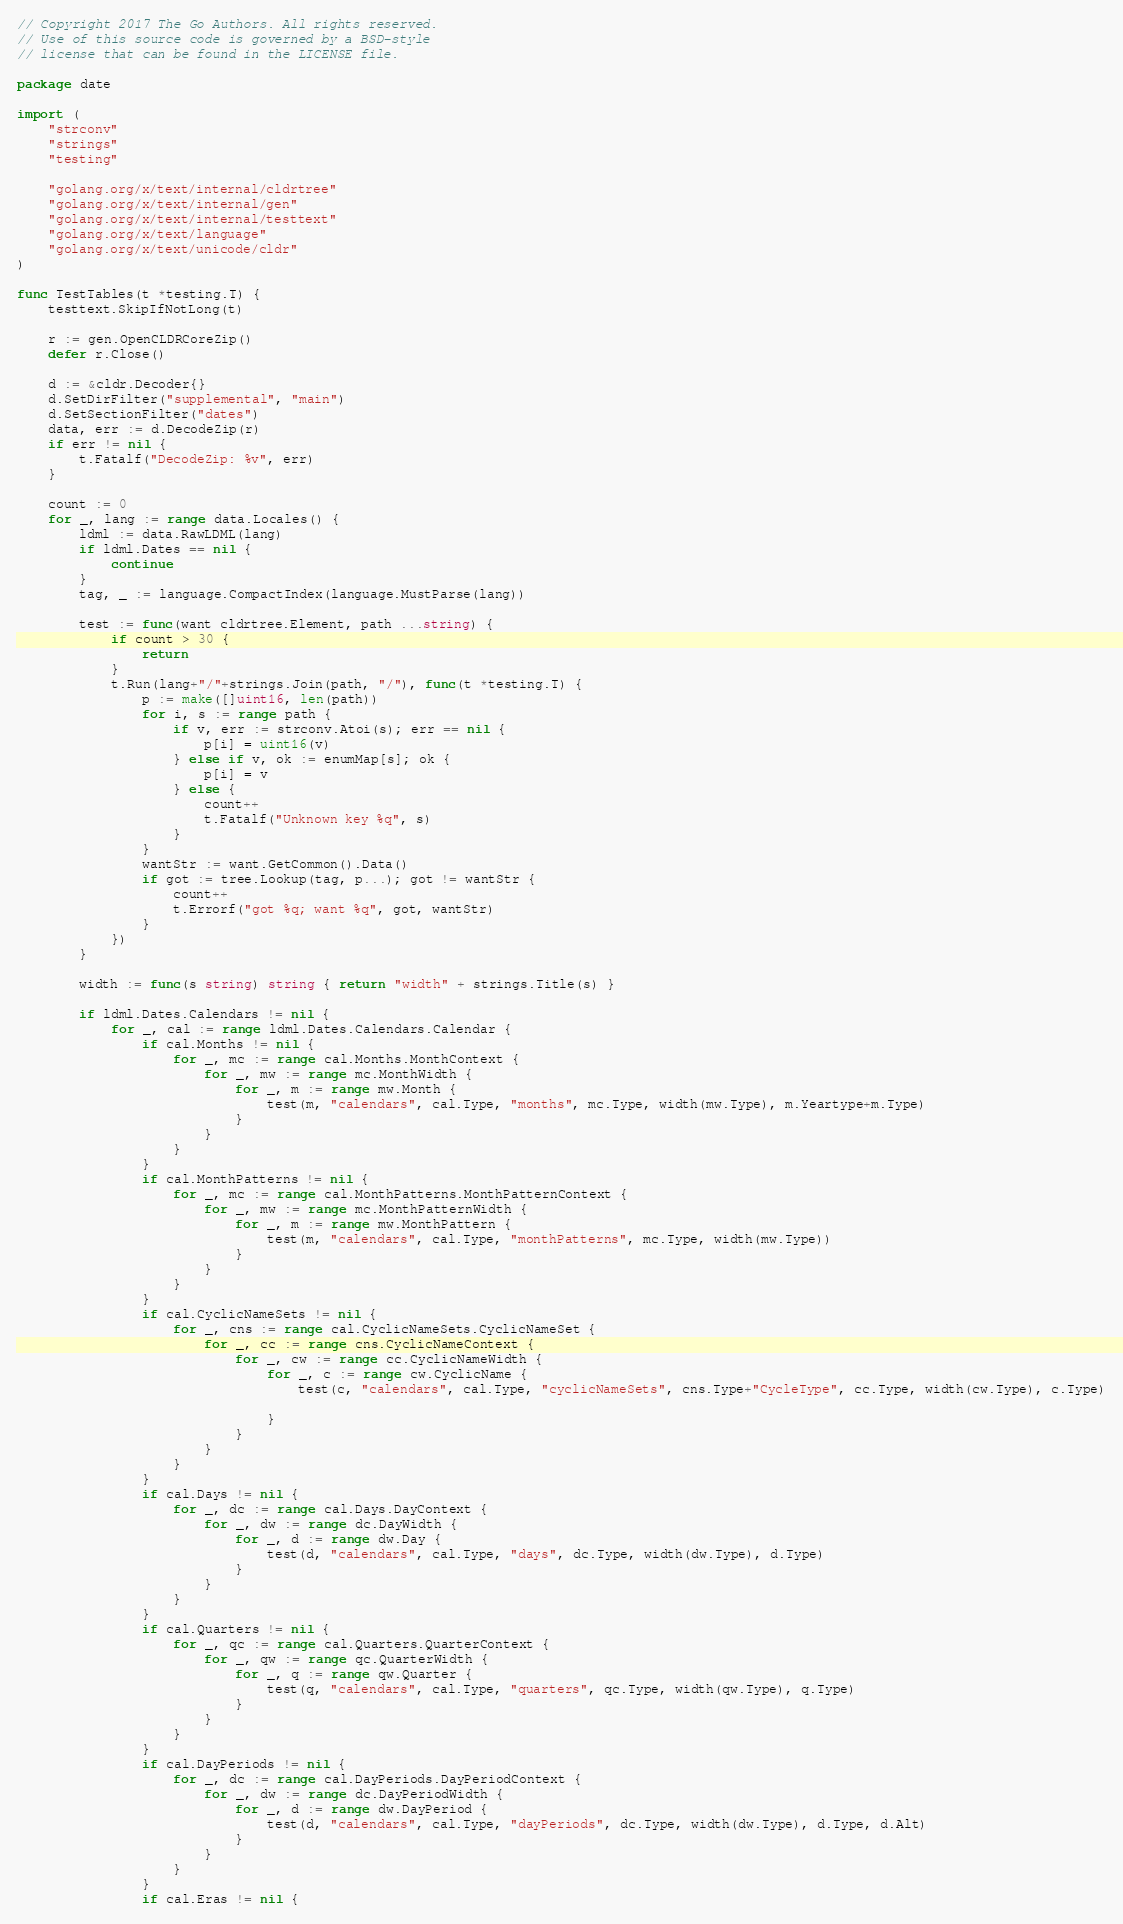Convert code to text. <code><loc_0><loc_0><loc_500><loc_500><_Go_>// Copyright 2017 The Go Authors. All rights reserved.
// Use of this source code is governed by a BSD-style
// license that can be found in the LICENSE file.

package date

import (
	"strconv"
	"strings"
	"testing"

	"golang.org/x/text/internal/cldrtree"
	"golang.org/x/text/internal/gen"
	"golang.org/x/text/internal/testtext"
	"golang.org/x/text/language"
	"golang.org/x/text/unicode/cldr"
)

func TestTables(t *testing.T) {
	testtext.SkipIfNotLong(t)

	r := gen.OpenCLDRCoreZip()
	defer r.Close()

	d := &cldr.Decoder{}
	d.SetDirFilter("supplemental", "main")
	d.SetSectionFilter("dates")
	data, err := d.DecodeZip(r)
	if err != nil {
		t.Fatalf("DecodeZip: %v", err)
	}

	count := 0
	for _, lang := range data.Locales() {
		ldml := data.RawLDML(lang)
		if ldml.Dates == nil {
			continue
		}
		tag, _ := language.CompactIndex(language.MustParse(lang))

		test := func(want cldrtree.Element, path ...string) {
			if count > 30 {
				return
			}
			t.Run(lang+"/"+strings.Join(path, "/"), func(t *testing.T) {
				p := make([]uint16, len(path))
				for i, s := range path {
					if v, err := strconv.Atoi(s); err == nil {
						p[i] = uint16(v)
					} else if v, ok := enumMap[s]; ok {
						p[i] = v
					} else {
						count++
						t.Fatalf("Unknown key %q", s)
					}
				}
				wantStr := want.GetCommon().Data()
				if got := tree.Lookup(tag, p...); got != wantStr {
					count++
					t.Errorf("got %q; want %q", got, wantStr)
				}
			})
		}

		width := func(s string) string { return "width" + strings.Title(s) }

		if ldml.Dates.Calendars != nil {
			for _, cal := range ldml.Dates.Calendars.Calendar {
				if cal.Months != nil {
					for _, mc := range cal.Months.MonthContext {
						for _, mw := range mc.MonthWidth {
							for _, m := range mw.Month {
								test(m, "calendars", cal.Type, "months", mc.Type, width(mw.Type), m.Yeartype+m.Type)
							}
						}
					}
				}
				if cal.MonthPatterns != nil {
					for _, mc := range cal.MonthPatterns.MonthPatternContext {
						for _, mw := range mc.MonthPatternWidth {
							for _, m := range mw.MonthPattern {
								test(m, "calendars", cal.Type, "monthPatterns", mc.Type, width(mw.Type))
							}
						}
					}
				}
				if cal.CyclicNameSets != nil {
					for _, cns := range cal.CyclicNameSets.CyclicNameSet {
						for _, cc := range cns.CyclicNameContext {
							for _, cw := range cc.CyclicNameWidth {
								for _, c := range cw.CyclicName {
									test(c, "calendars", cal.Type, "cyclicNameSets", cns.Type+"CycleType", cc.Type, width(cw.Type), c.Type)

								}
							}
						}
					}
				}
				if cal.Days != nil {
					for _, dc := range cal.Days.DayContext {
						for _, dw := range dc.DayWidth {
							for _, d := range dw.Day {
								test(d, "calendars", cal.Type, "days", dc.Type, width(dw.Type), d.Type)
							}
						}
					}
				}
				if cal.Quarters != nil {
					for _, qc := range cal.Quarters.QuarterContext {
						for _, qw := range qc.QuarterWidth {
							for _, q := range qw.Quarter {
								test(q, "calendars", cal.Type, "quarters", qc.Type, width(qw.Type), q.Type)
							}
						}
					}
				}
				if cal.DayPeriods != nil {
					for _, dc := range cal.DayPeriods.DayPeriodContext {
						for _, dw := range dc.DayPeriodWidth {
							for _, d := range dw.DayPeriod {
								test(d, "calendars", cal.Type, "dayPeriods", dc.Type, width(dw.Type), d.Type, d.Alt)
							}
						}
					}
				}
				if cal.Eras != nil {</code> 